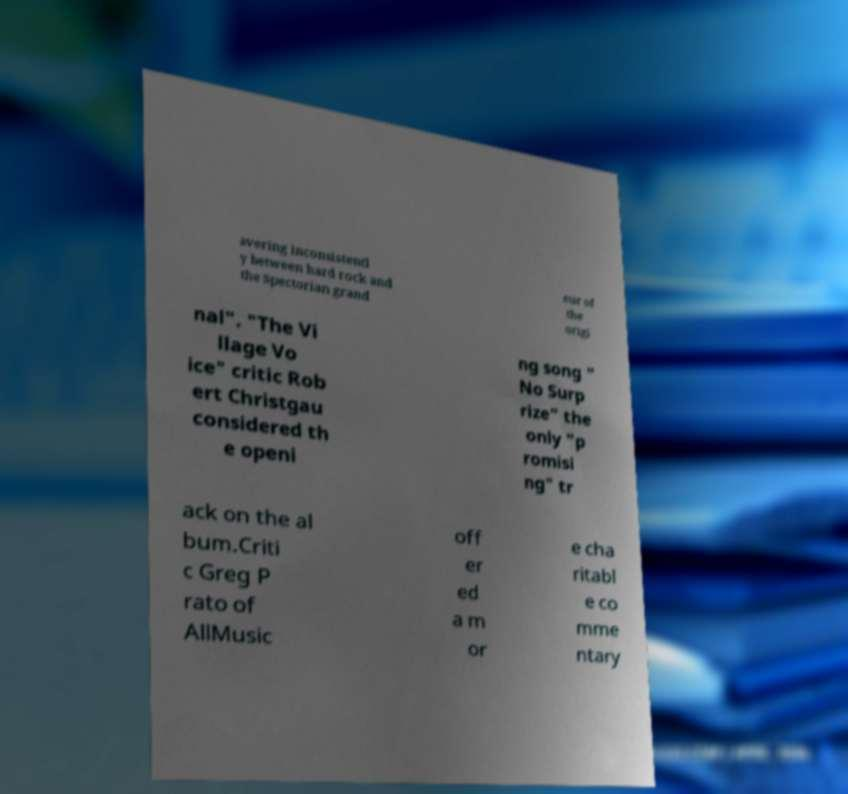Could you assist in decoding the text presented in this image and type it out clearly? avering inconsistentl y between hard rock and the Spectorian grand eur of the origi nal". "The Vi llage Vo ice" critic Rob ert Christgau considered th e openi ng song " No Surp rize" the only "p romisi ng" tr ack on the al bum.Criti c Greg P rato of AllMusic off er ed a m or e cha ritabl e co mme ntary 